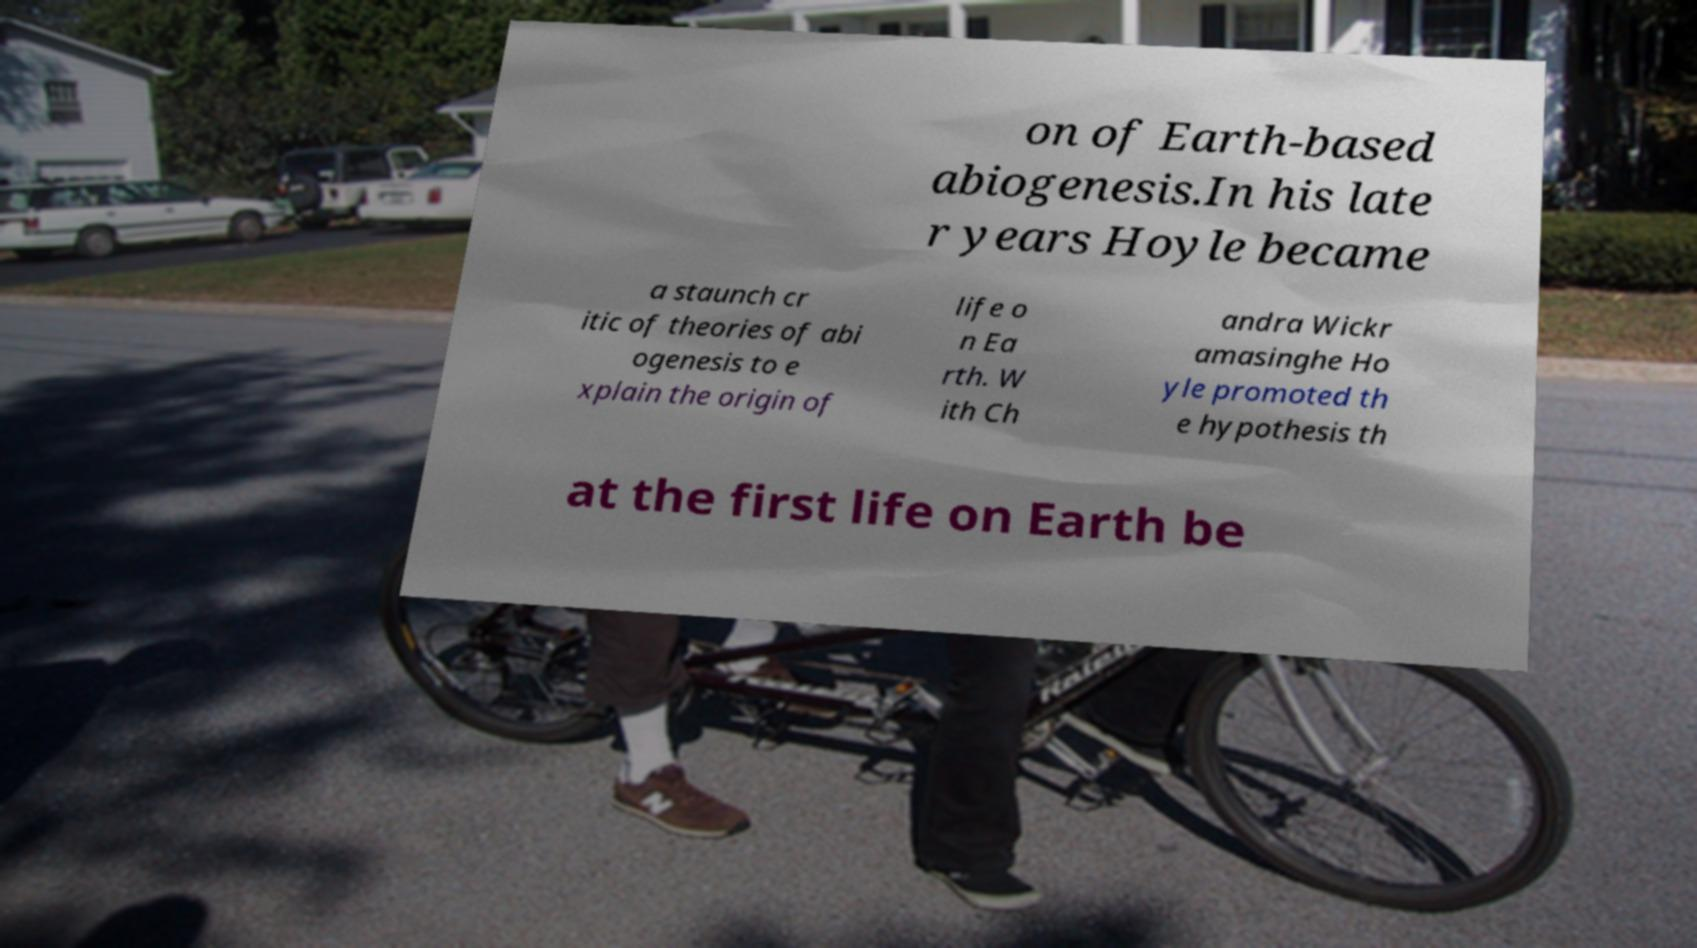For documentation purposes, I need the text within this image transcribed. Could you provide that? on of Earth-based abiogenesis.In his late r years Hoyle became a staunch cr itic of theories of abi ogenesis to e xplain the origin of life o n Ea rth. W ith Ch andra Wickr amasinghe Ho yle promoted th e hypothesis th at the first life on Earth be 